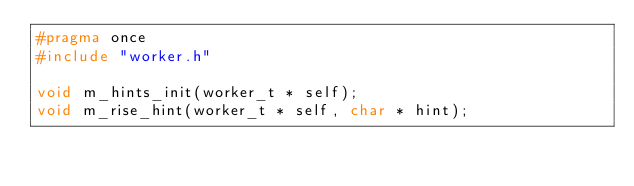Convert code to text. <code><loc_0><loc_0><loc_500><loc_500><_C_>#pragma once
#include "worker.h"

void m_hints_init(worker_t * self);
void m_rise_hint(worker_t * self, char * hint);</code> 